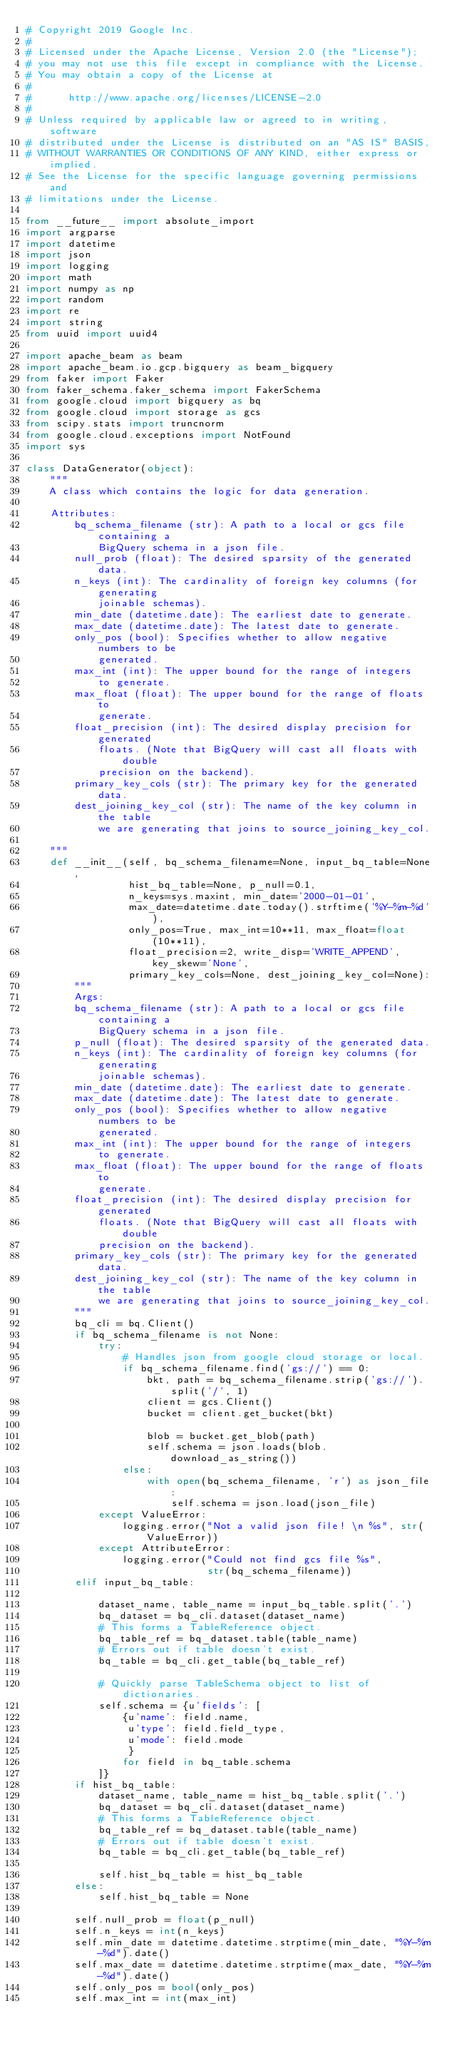<code> <loc_0><loc_0><loc_500><loc_500><_Python_># Copyright 2019 Google Inc.
#
# Licensed under the Apache License, Version 2.0 (the "License");
# you may not use this file except in compliance with the License.
# You may obtain a copy of the License at
#
#      http://www.apache.org/licenses/LICENSE-2.0
#
# Unless required by applicable law or agreed to in writing, software
# distributed under the License is distributed on an "AS IS" BASIS,
# WITHOUT WARRANTIES OR CONDITIONS OF ANY KIND, either express or implied.
# See the License for the specific language governing permissions and
# limitations under the License.

from __future__ import absolute_import
import argparse
import datetime
import json
import logging
import math
import numpy as np
import random
import re
import string
from uuid import uuid4

import apache_beam as beam
import apache_beam.io.gcp.bigquery as beam_bigquery
from faker import Faker
from faker_schema.faker_schema import FakerSchema
from google.cloud import bigquery as bq
from google.cloud import storage as gcs
from scipy.stats import truncnorm
from google.cloud.exceptions import NotFound
import sys

class DataGenerator(object):
    """
    A class which contains the logic for data generation.

    Attributes:
        bq_schema_filename (str): A path to a local or gcs file containing a
            BigQuery schema in a json file.
        null_prob (float): The desired sparsity of the generated data.
        n_keys (int): The cardinality of foreign key columns (for generating
            joinable schemas).
        min_date (datetime.date): The earliest date to generate.
        max_date (datetime.date): The latest date to generate.
        only_pos (bool): Specifies whether to allow negative numbers to be
            generated.
        max_int (int): The upper bound for the range of integers
            to generate.
        max_float (float): The upper bound for the range of floats to
            generate.
        float_precision (int): The desired display precision for generated
            floats. (Note that BigQuery will cast all floats with double
            precision on the backend).
        primary_key_cols (str): The primary key for the generated data.
        dest_joining_key_col (str): The name of the key column in the table
            we are generating that joins to source_joining_key_col.

    """
    def __init__(self, bq_schema_filename=None, input_bq_table=None, 
                 hist_bq_table=None, p_null=0.1,
                 n_keys=sys.maxint, min_date='2000-01-01',
                 max_date=datetime.date.today().strftime('%Y-%m-%d'),
                 only_pos=True, max_int=10**11, max_float=float(10**11),
                 float_precision=2, write_disp='WRITE_APPEND', key_skew='None',
                 primary_key_cols=None, dest_joining_key_col=None):
        """
        Args:
        bq_schema_filename (str): A path to a local or gcs file containing a
            BigQuery schema in a json file.
        p_null (float): The desired sparsity of the generated data.
        n_keys (int): The cardinality of foreign key columns (for generating
            joinable schemas).
        min_date (datetime.date): The earliest date to generate.
        max_date (datetime.date): The latest date to generate.
        only_pos (bool): Specifies whether to allow negative numbers to be
            generated.
        max_int (int): The upper bound for the range of integers
            to generate.
        max_float (float): The upper bound for the range of floats to
            generate.
        float_precision (int): The desired display precision for generated
            floats. (Note that BigQuery will cast all floats with double
            precision on the backend).
        primary_key_cols (str): The primary key for the generated data.
        dest_joining_key_col (str): The name of the key column in the table
            we are generating that joins to source_joining_key_col.
        """
        bq_cli = bq.Client()
        if bq_schema_filename is not None:
            try:
                # Handles json from google cloud storage or local.
                if bq_schema_filename.find('gs://') == 0:
                    bkt, path = bq_schema_filename.strip('gs://').split('/', 1)
                    client = gcs.Client()
                    bucket = client.get_bucket(bkt)

                    blob = bucket.get_blob(path)
                    self.schema = json.loads(blob.download_as_string())
                else:
                    with open(bq_schema_filename, 'r') as json_file:
                        self.schema = json.load(json_file)
            except ValueError:
                logging.error("Not a valid json file! \n %s", str(ValueError))
            except AttributeError:
                logging.error("Could not find gcs file %s",
                              str(bq_schema_filename))
        elif input_bq_table:

            dataset_name, table_name = input_bq_table.split('.')
            bq_dataset = bq_cli.dataset(dataset_name)
            # This forms a TableReference object.
            bq_table_ref = bq_dataset.table(table_name)
            # Errors out if table doesn't exist.
            bq_table = bq_cli.get_table(bq_table_ref)

            # Quickly parse TableSchema object to list of dictionaries.
            self.schema = {u'fields': [
                {u'name': field.name,
                 u'type': field.field_type,
                 u'mode': field.mode
                 }
                for field in bq_table.schema
            ]}
        if hist_bq_table:
            dataset_name, table_name = hist_bq_table.split('.')
            bq_dataset = bq_cli.dataset(dataset_name)
            # This forms a TableReference object.
            bq_table_ref = bq_dataset.table(table_name)
            # Errors out if table doesn't exist.
            bq_table = bq_cli.get_table(bq_table_ref)

            self.hist_bq_table = hist_bq_table
        else:
            self.hist_bq_table = None

        self.null_prob = float(p_null)
        self.n_keys = int(n_keys)
        self.min_date = datetime.datetime.strptime(min_date, "%Y-%m-%d").date()
        self.max_date = datetime.datetime.strptime(max_date, "%Y-%m-%d").date()
        self.only_pos = bool(only_pos)
        self.max_int = int(max_int)</code> 